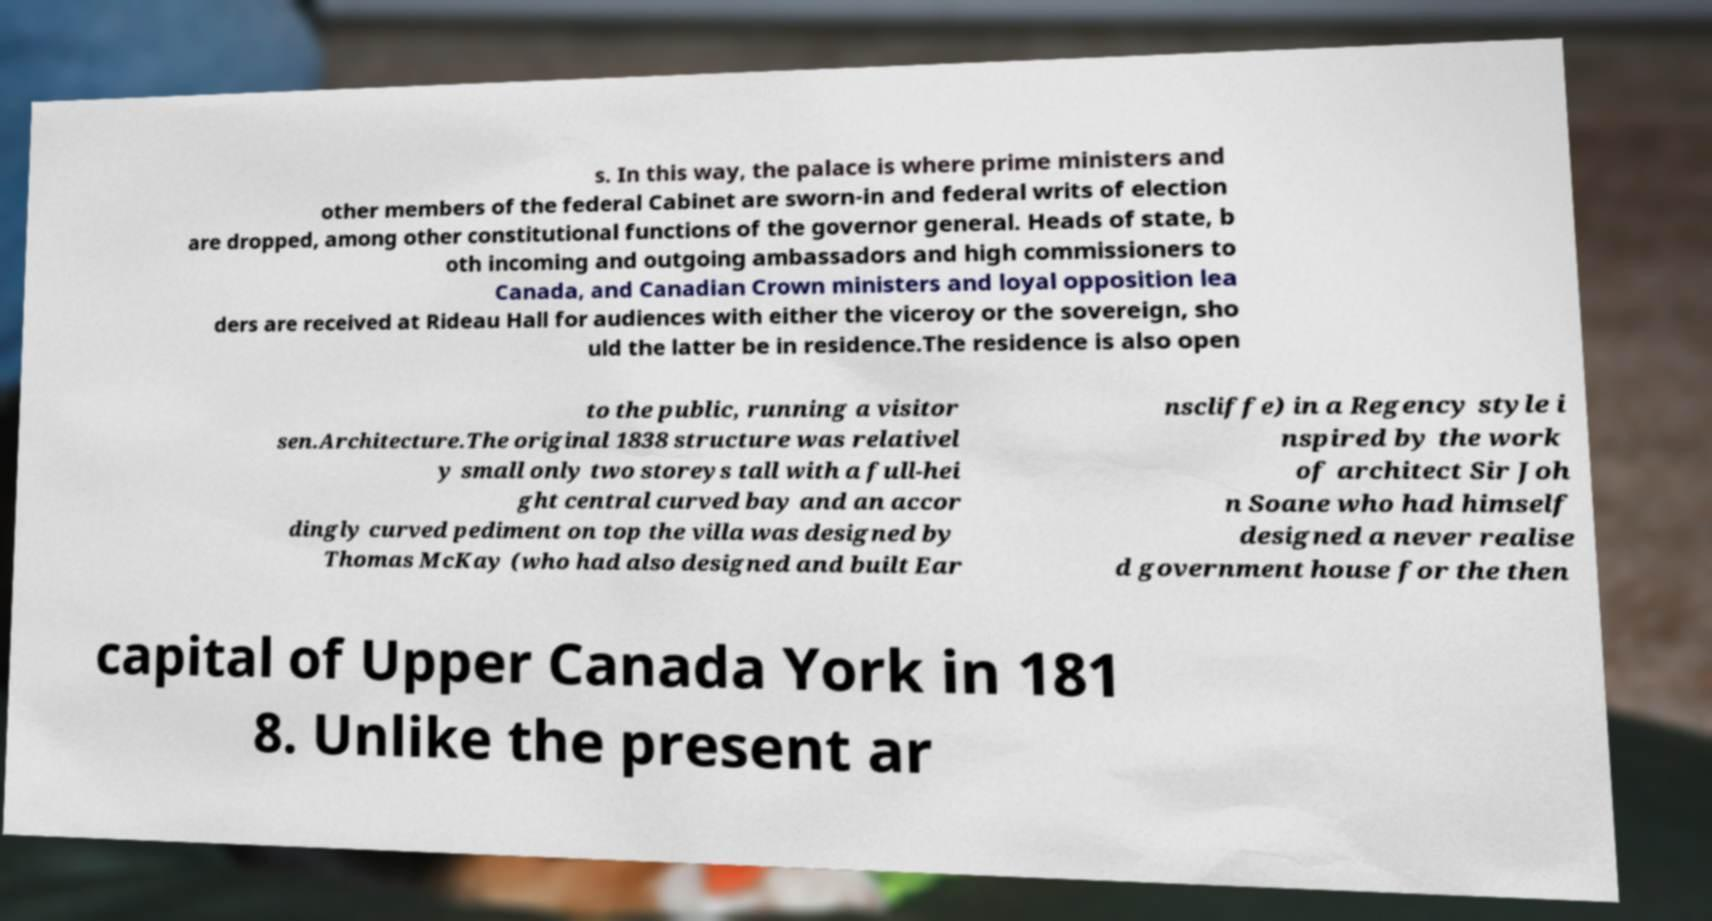Please read and relay the text visible in this image. What does it say? s. In this way, the palace is where prime ministers and other members of the federal Cabinet are sworn-in and federal writs of election are dropped, among other constitutional functions of the governor general. Heads of state, b oth incoming and outgoing ambassadors and high commissioners to Canada, and Canadian Crown ministers and loyal opposition lea ders are received at Rideau Hall for audiences with either the viceroy or the sovereign, sho uld the latter be in residence.The residence is also open to the public, running a visitor sen.Architecture.The original 1838 structure was relativel y small only two storeys tall with a full-hei ght central curved bay and an accor dingly curved pediment on top the villa was designed by Thomas McKay (who had also designed and built Ear nscliffe) in a Regency style i nspired by the work of architect Sir Joh n Soane who had himself designed a never realise d government house for the then capital of Upper Canada York in 181 8. Unlike the present ar 